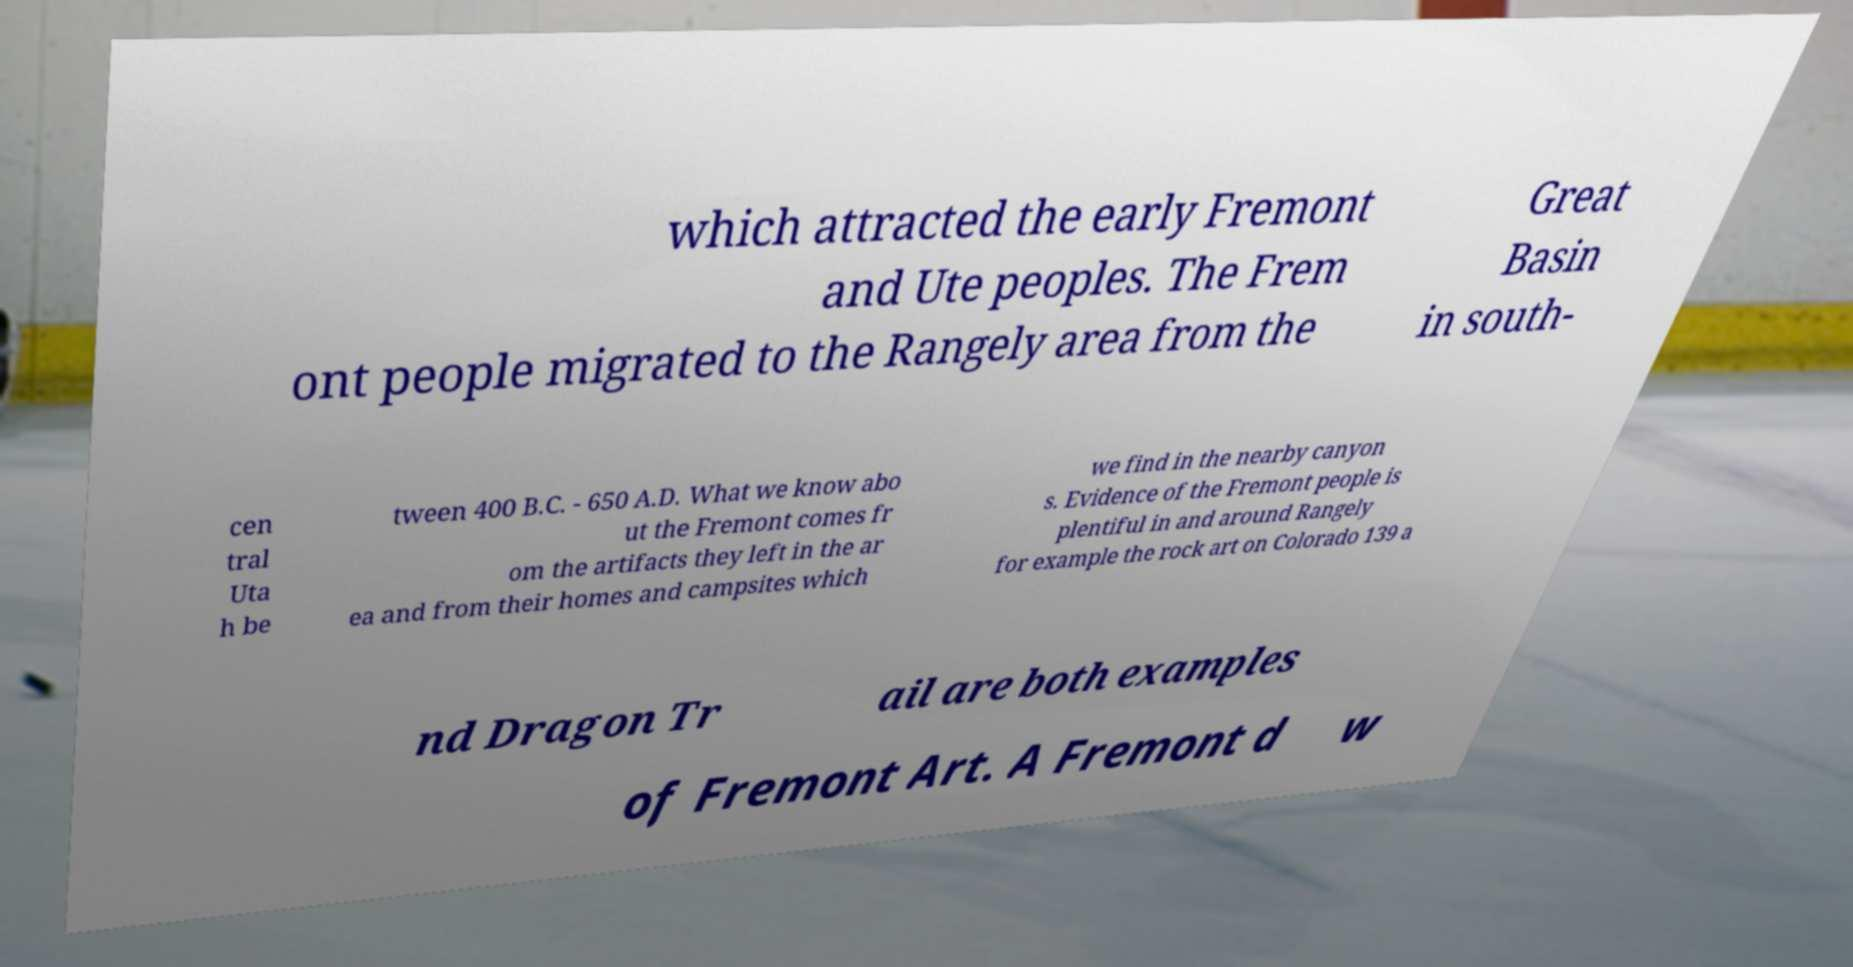I need the written content from this picture converted into text. Can you do that? which attracted the early Fremont and Ute peoples. The Frem ont people migrated to the Rangely area from the Great Basin in south- cen tral Uta h be tween 400 B.C. - 650 A.D. What we know abo ut the Fremont comes fr om the artifacts they left in the ar ea and from their homes and campsites which we find in the nearby canyon s. Evidence of the Fremont people is plentiful in and around Rangely for example the rock art on Colorado 139 a nd Dragon Tr ail are both examples of Fremont Art. A Fremont d w 